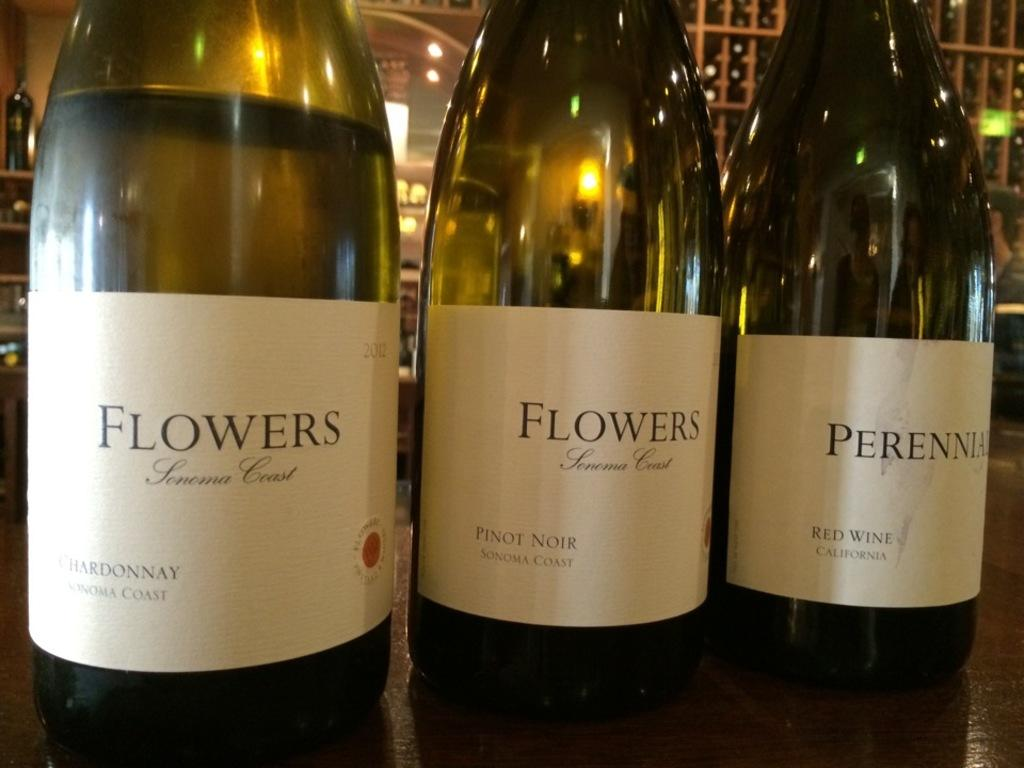<image>
Give a short and clear explanation of the subsequent image. Bottles of alcohol next to one another with one that says "FLOWERS". 